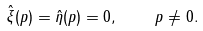Convert formula to latex. <formula><loc_0><loc_0><loc_500><loc_500>\hat { \xi } ( p ) = \hat { \eta } ( p ) = 0 , \quad p \neq 0 .</formula> 